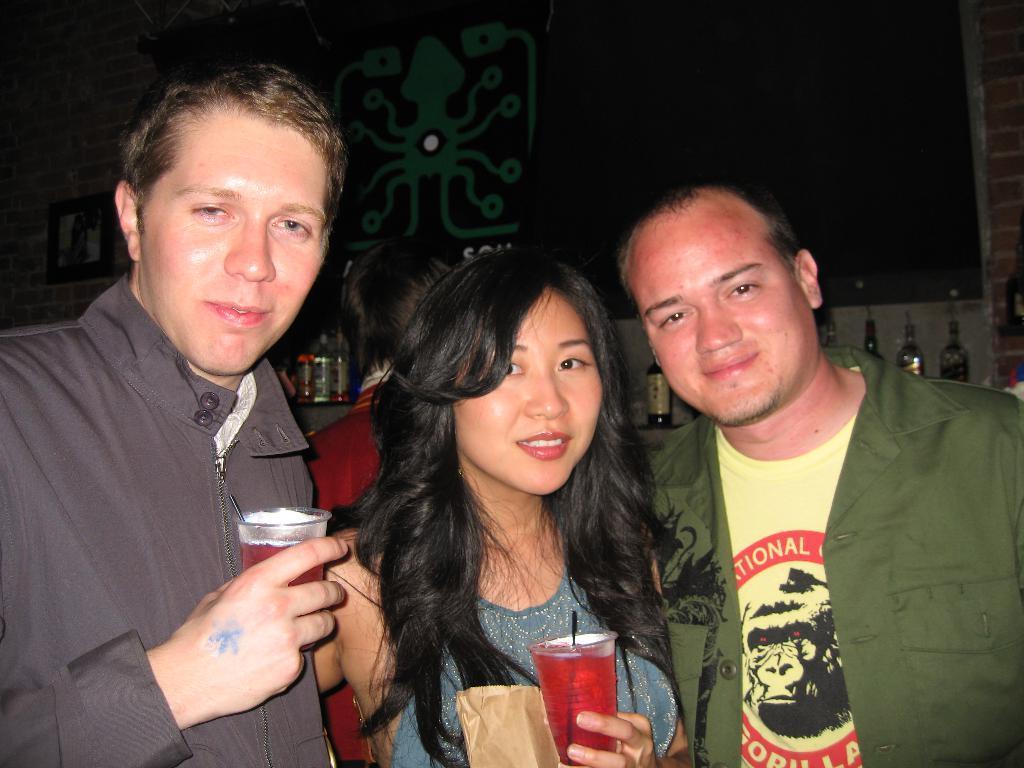In one or two sentences, can you explain what this image depicts? This picture shows of two men and a woman in the middle holding a cup with some drink in her hand. The left side man is also holding a cup in his hand. In the background, there are some bottles and all of them were smiling here. 